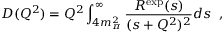Convert formula to latex. <formula><loc_0><loc_0><loc_500><loc_500>D ( Q ^ { 2 } ) = Q ^ { 2 } \int _ { 4 m _ { \pi } ^ { 2 } } ^ { \infty } \frac { R ^ { e x p } ( s ) } { ( s + Q ^ { 2 } ) ^ { 2 } } d s \, ,</formula> 